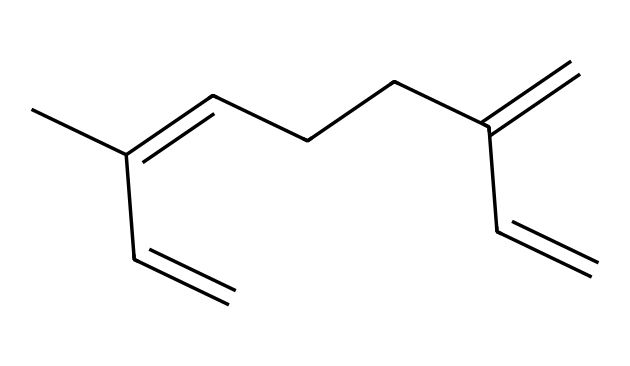how many carbon atoms are in myrcene? The SMILES representation shows "CC(=CCCC(=C)C=C)", which indicates that there are a total of 10 carbon atoms in the structure. Each "C" corresponds to a carbon atom we count.
Answer: ten what type of chemical is myrcene? Myrcene is identified as a terpene, which is a specific class of organic compounds derived from plants, commonly known for their aromatic properties.
Answer: terpene how many double bonds are present in myrcene? Analyzing the SMILES representation, we see the "=" symbol is used to denote double bonds, which appear three times in myrcene. Thus, there are three double bonds present.
Answer: three what is the main functional group in myrcene? In myrcene, the structure primarily features alkenes, which are hydrocarbons that contain double bonds. The double bonded carbons indicate the presence of this functional group.
Answer: alkene is myrcene soluble in water? Terpenes like myrcene have non-polar attributes due to their hydrocarbon structure, making them generally insoluble in water which is polar.
Answer: no which type of natural scents does myrcene contribute to? Myrcene adds to the scent profile of cannabis and various fruits like mangoes, contributing to a fruity and earthy aroma commonly associated with tropical scents.
Answer: fruity 